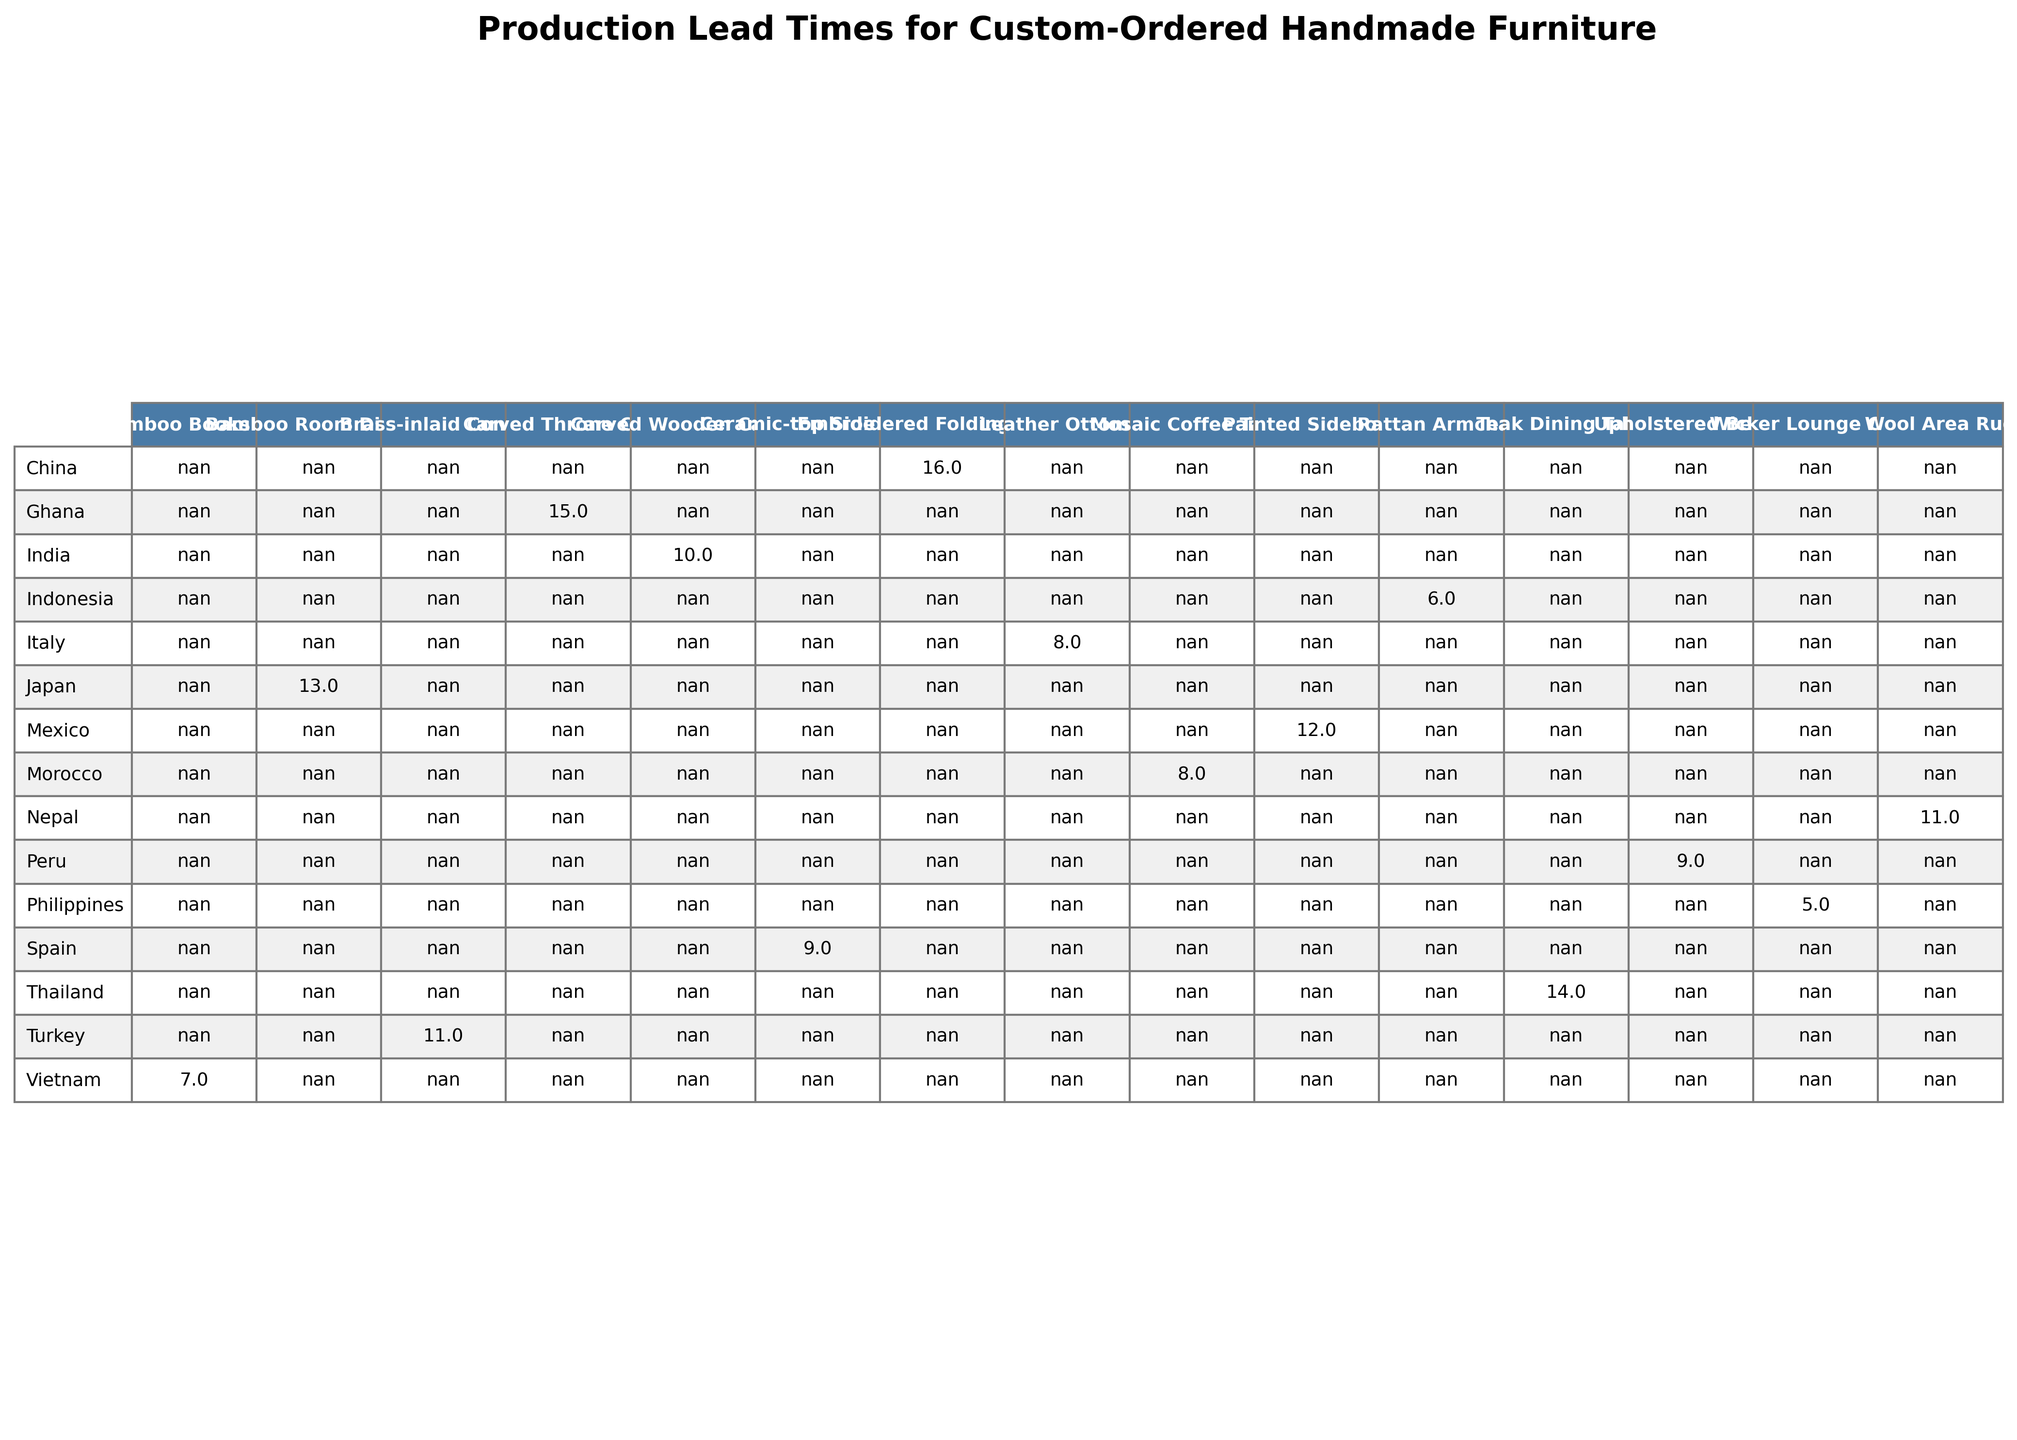What's the longest lead time for a custom-ordered handmade furniture item? From the table, the longest lead time, indicated in weeks, is 16 weeks, which corresponds to the Embroidered Folding Screen from Suzhou Silk Embroiderers in China.
Answer: 16 weeks Which country has the shortest production lead time for custom-ordered handmade furniture? The table shows that the Philippines has the shortest lead time of 5 weeks for the Wicker Lounge Chair, making it the country with the quickest production time.
Answer: Philippines How many countries have a lead time of 10 weeks or more? By examining the table, there are 6 countries with lead times of 10 weeks or more: India, Turkey, Mexico, Thailand, Ghana, and China.
Answer: 6 What's the average lead time for custom furniture from all artisans listed? The total lead time is calculated by summing the lead times (10+8+6+12+14+7+9+11+5+15+13+8+16+9+11) =  12, and then dividing by the total number of artisans, which is 15:  12/15 = 10.8, so the average is approximately 10.67 weeks.
Answer: 10.67 weeks Is there any artisan from Vietnam with a lead time less than 8 weeks? Referencing the table, Vietnam has an artisan, Hanoi Bamboo Craftsmen, whose lead time is 7 weeks, which is indeed less than 8 weeks.
Answer: Yes What is the difference in lead time between the longest and shortest production times for custom furniture? The longest lead time is 16 weeks for the Embroidered Folding Screen and the shortest is 5 weeks for the Wicker Lounge Chair, so the difference is calculated as 16 - 5 = 11 weeks.
Answer: 11 weeks Which artisan produces the Teak Dining Table, and what is its lead time? From the table, the Teak Dining Table is produced by the Chiang Mai Teak Masters from Thailand, and the lead time is 14 weeks.
Answer: Chiang Mai Teak Masters, 14 weeks How many artisans have lead times of less than 10 weeks? Focusing on the table, the artisans with lead times under 10 weeks are the Bali Rattan Weavers, Hanoi Bamboo Craftsmen, Cebu Wicker Experts, and Oaxacan Woodworkers, totaling 4 artisans.
Answer: 4 artisans Which is the only artisan from Ghana, and what is their lead time for custom furniture? The table indicates that Accra Wood Carvers is the only artisan listed from Ghana, with a production lead time of 15 weeks.
Answer: Accra Wood Carvers, 15 weeks What is the total lead time for all furniture types produced in Mexico? According to the table, the only furniture type produced in Mexico is the Painted Sideboard, which has a lead time of 12 weeks. Therefore, the total lead time for furniture from Mexico remains 12 weeks.
Answer: 12 weeks 